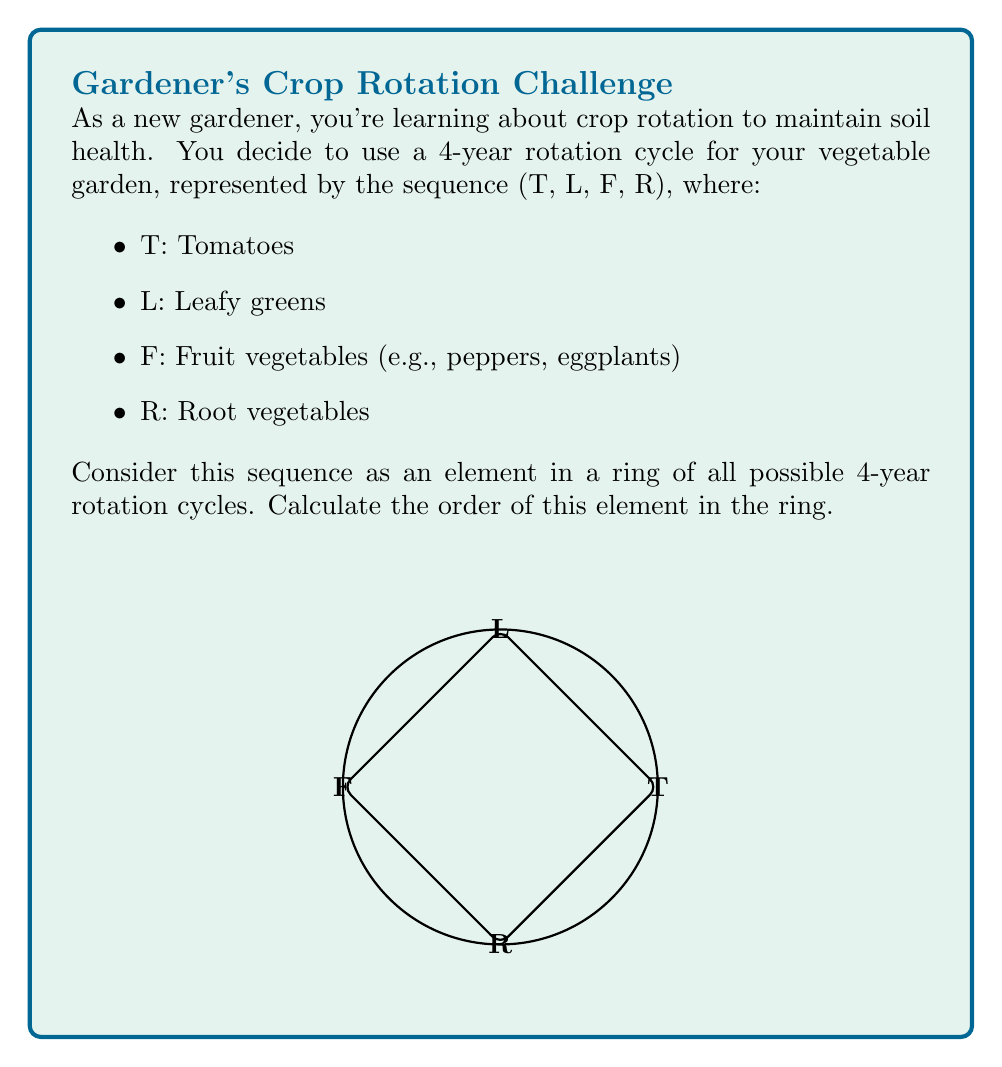Could you help me with this problem? To solve this problem, we need to understand the concept of order in ring theory and how it applies to our crop rotation sequence.

1) In ring theory, the order of an element is the smallest positive integer $n$ such that the element raised to the power $n$ equals the identity element.

2) In our case, the operation is cyclic permutation, and the identity element is the original sequence (T, L, F, R).

3) Let's see what happens when we apply the operation multiple times:
   (T, L, F, R) original
   (R, T, L, F) after 1 rotation
   (F, R, T, L) after 2 rotations
   (L, F, R, T) after 3 rotations
   (T, L, F, R) after 4 rotations

4) We see that after 4 rotations, we return to the original sequence.

5) Therefore, the order of this element in the ring is 4.

This means that after completing 4 full rotation cycles, your garden will return to its original planting arrangement.
Answer: 4 